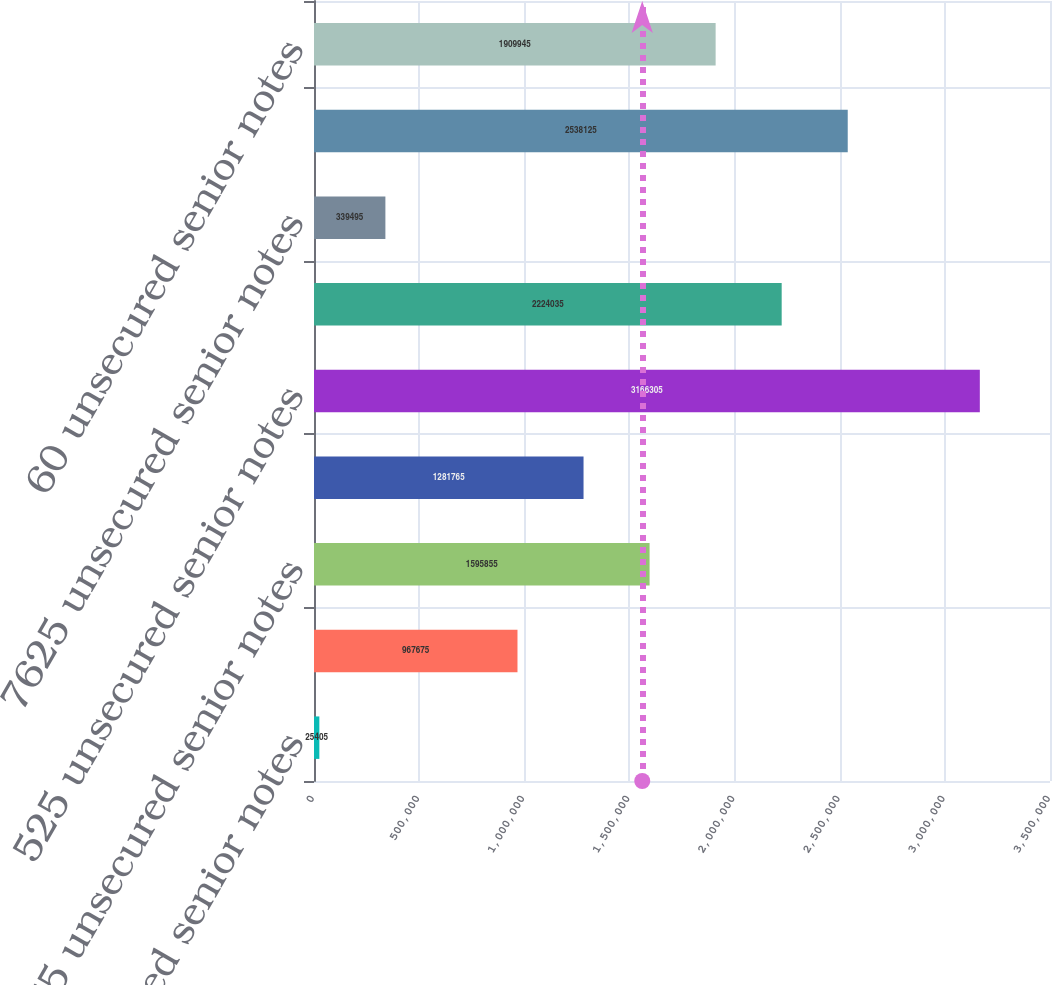Convert chart to OTSL. <chart><loc_0><loc_0><loc_500><loc_500><bar_chart><fcel>4875 unsecured senior notes<fcel>8125 unsecured senior notes<fcel>7875 unsecured senior notes<fcel>625 unsecured senior notes<fcel>525 unsecured senior notes<fcel>52 unsecured senior notes<fcel>7625 unsecured senior notes<fcel>6375 unsecured senior notes<fcel>60 unsecured senior notes<nl><fcel>25405<fcel>967675<fcel>1.59586e+06<fcel>1.28176e+06<fcel>3.1663e+06<fcel>2.22404e+06<fcel>339495<fcel>2.53812e+06<fcel>1.90994e+06<nl></chart> 